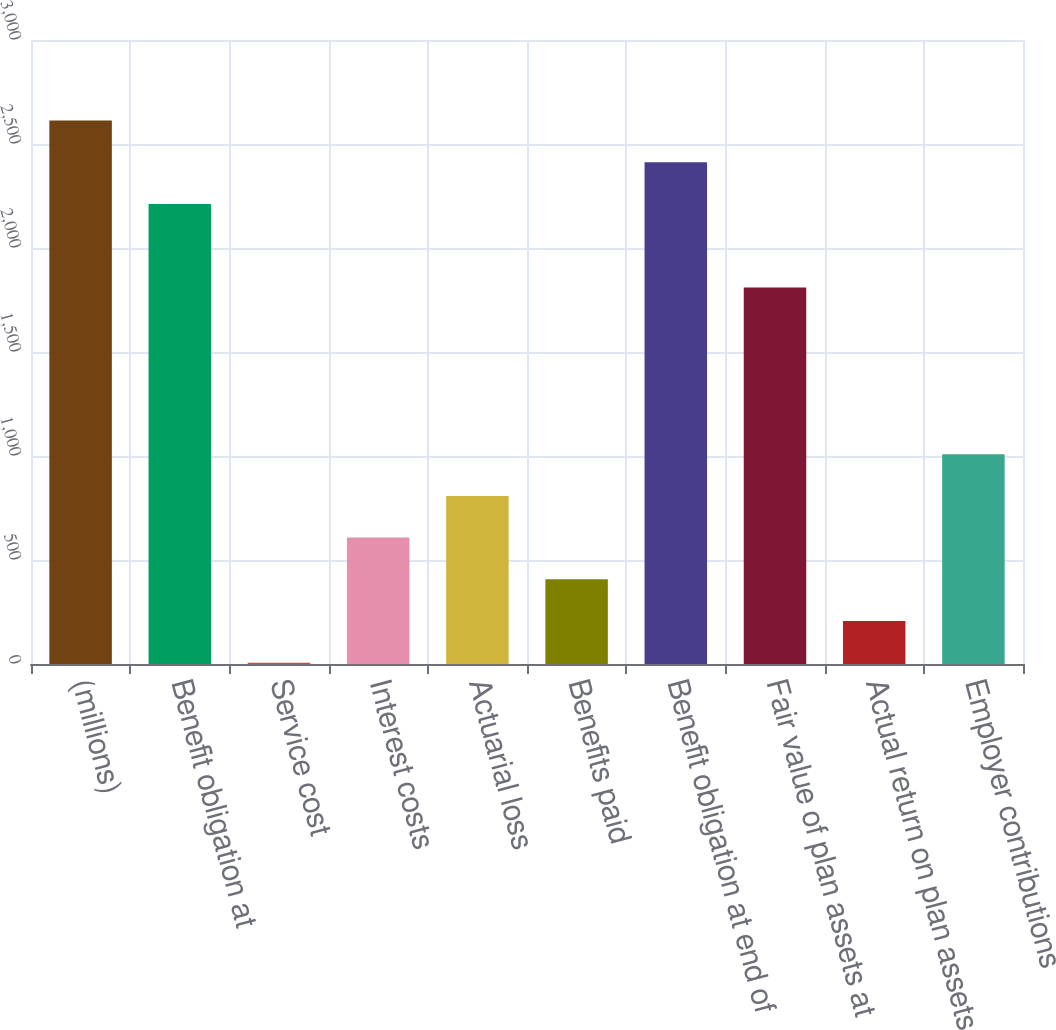Convert chart to OTSL. <chart><loc_0><loc_0><loc_500><loc_500><bar_chart><fcel>(millions)<fcel>Benefit obligation at<fcel>Service cost<fcel>Interest costs<fcel>Actuarial loss<fcel>Benefits paid<fcel>Benefit obligation at end of<fcel>Fair value of plan assets at<fcel>Actual return on plan assets<fcel>Employer contributions<nl><fcel>2612.44<fcel>2211.48<fcel>6.2<fcel>607.64<fcel>808.12<fcel>407.16<fcel>2411.96<fcel>1810.52<fcel>206.68<fcel>1008.6<nl></chart> 